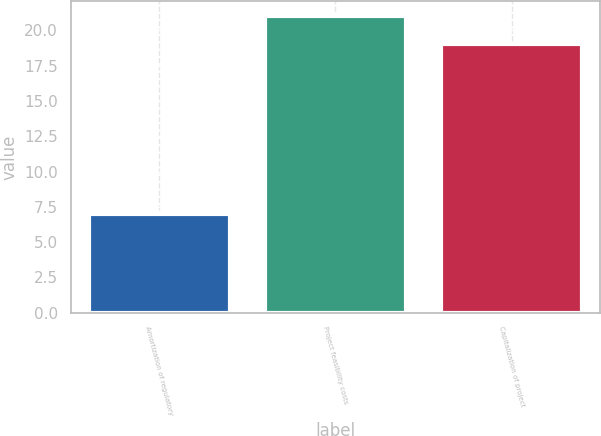<chart> <loc_0><loc_0><loc_500><loc_500><bar_chart><fcel>Amortization of regulatory<fcel>Project feasibility costs<fcel>Capitalization of project<nl><fcel>7<fcel>21<fcel>19<nl></chart> 